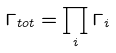Convert formula to latex. <formula><loc_0><loc_0><loc_500><loc_500>\Gamma _ { t o t } = \prod _ { i } \Gamma _ { i }</formula> 